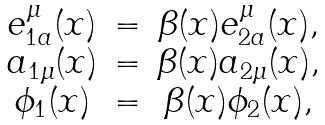Convert formula to latex. <formula><loc_0><loc_0><loc_500><loc_500>\begin{array} { c c c } e ^ { \mu } _ { 1 a } ( x ) & = & \beta ( x ) e ^ { \mu } _ { 2 a } ( x ) , \\ a _ { 1 \mu } ( x ) & = & \beta ( x ) a _ { 2 \mu } ( x ) , \\ \phi _ { 1 } ( x ) & = & \beta ( x ) \phi _ { 2 } ( x ) , \end{array}</formula> 